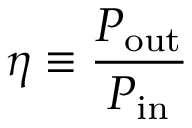Convert formula to latex. <formula><loc_0><loc_0><loc_500><loc_500>\eta \equiv \frac { P _ { o u t } } { P _ { i n } }</formula> 